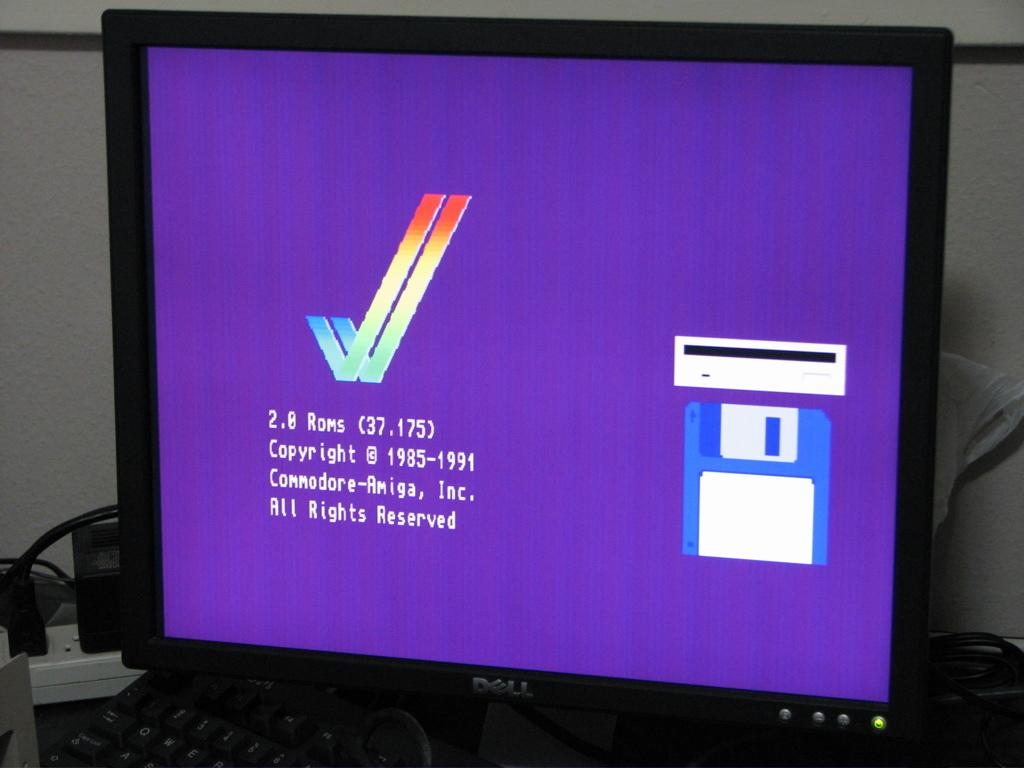<image>
Render a clear and concise summary of the photo. A Dell computer shows a purple screen saying there are 2.0 Roms. 